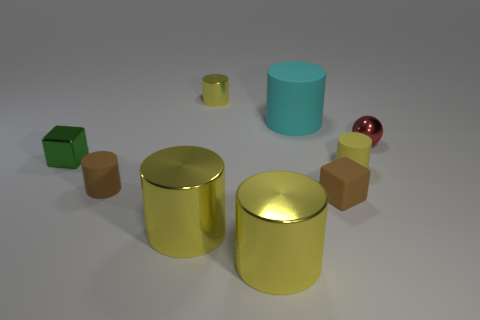Subtract all brown cylinders. How many cylinders are left? 5 Subtract all cyan cylinders. How many cylinders are left? 5 Subtract all blocks. How many objects are left? 7 Add 1 tiny things. How many objects exist? 10 Subtract 1 green blocks. How many objects are left? 8 Subtract 1 cylinders. How many cylinders are left? 5 Subtract all yellow cubes. Subtract all yellow cylinders. How many cubes are left? 2 Subtract all green cylinders. How many brown balls are left? 0 Subtract all large yellow matte blocks. Subtract all small green blocks. How many objects are left? 8 Add 8 cyan cylinders. How many cyan cylinders are left? 9 